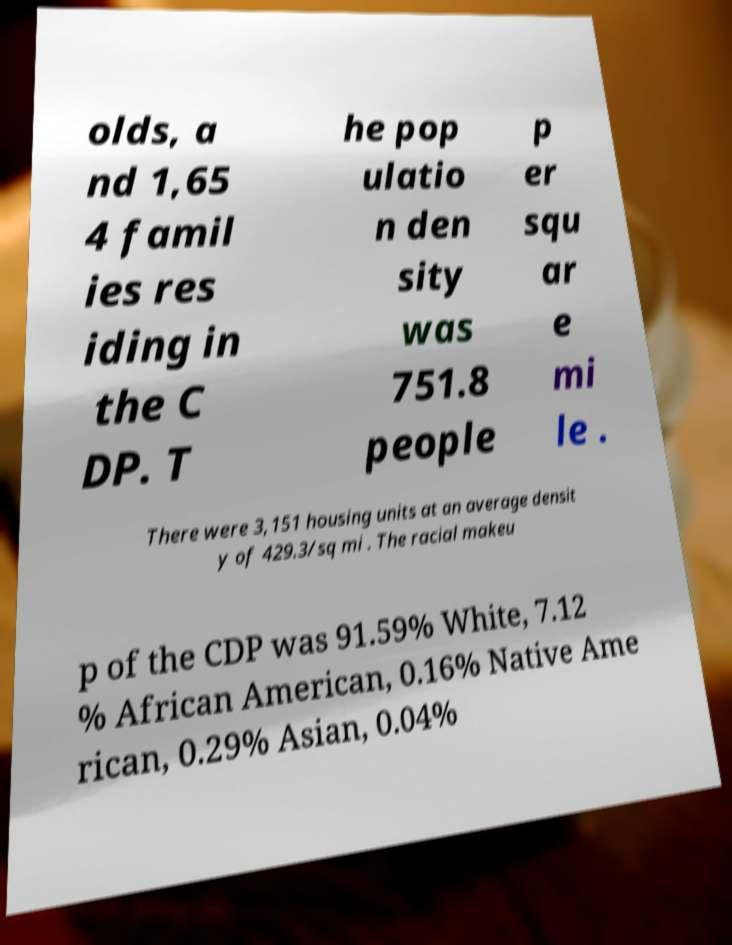Can you accurately transcribe the text from the provided image for me? olds, a nd 1,65 4 famil ies res iding in the C DP. T he pop ulatio n den sity was 751.8 people p er squ ar e mi le . There were 3,151 housing units at an average densit y of 429.3/sq mi . The racial makeu p of the CDP was 91.59% White, 7.12 % African American, 0.16% Native Ame rican, 0.29% Asian, 0.04% 